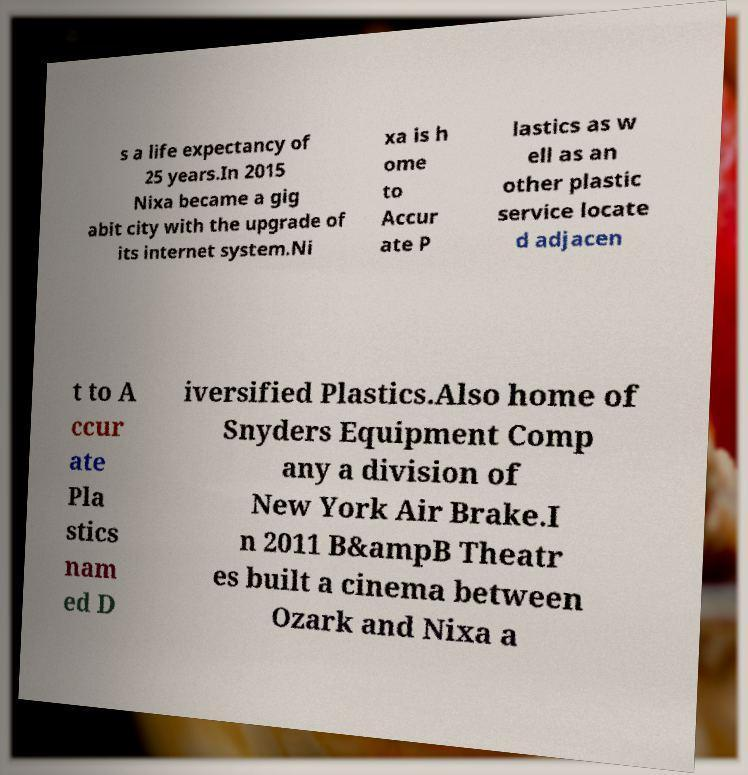For documentation purposes, I need the text within this image transcribed. Could you provide that? s a life expectancy of 25 years.In 2015 Nixa became a gig abit city with the upgrade of its internet system.Ni xa is h ome to Accur ate P lastics as w ell as an other plastic service locate d adjacen t to A ccur ate Pla stics nam ed D iversified Plastics.Also home of Snyders Equipment Comp any a division of New York Air Brake.I n 2011 B&ampB Theatr es built a cinema between Ozark and Nixa a 